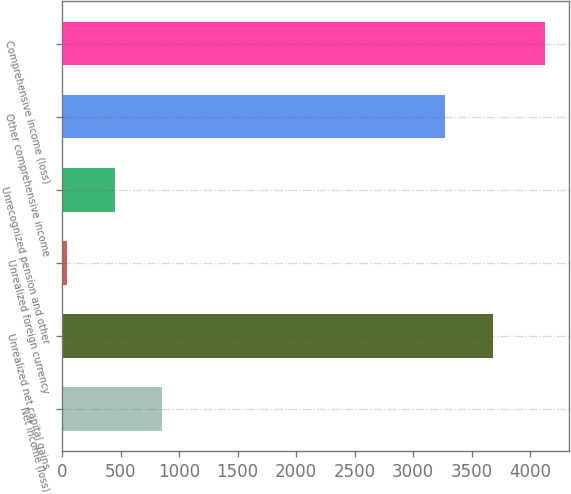Convert chart. <chart><loc_0><loc_0><loc_500><loc_500><bar_chart><fcel>Net income (loss)<fcel>Unrealized net capital gains<fcel>Unrealized foreign currency<fcel>Unrecognized pension and other<fcel>Other comprehensive income<fcel>Comprehensive income (loss)<nl><fcel>858.2<fcel>3681.6<fcel>41<fcel>449.6<fcel>3273<fcel>4127<nl></chart> 